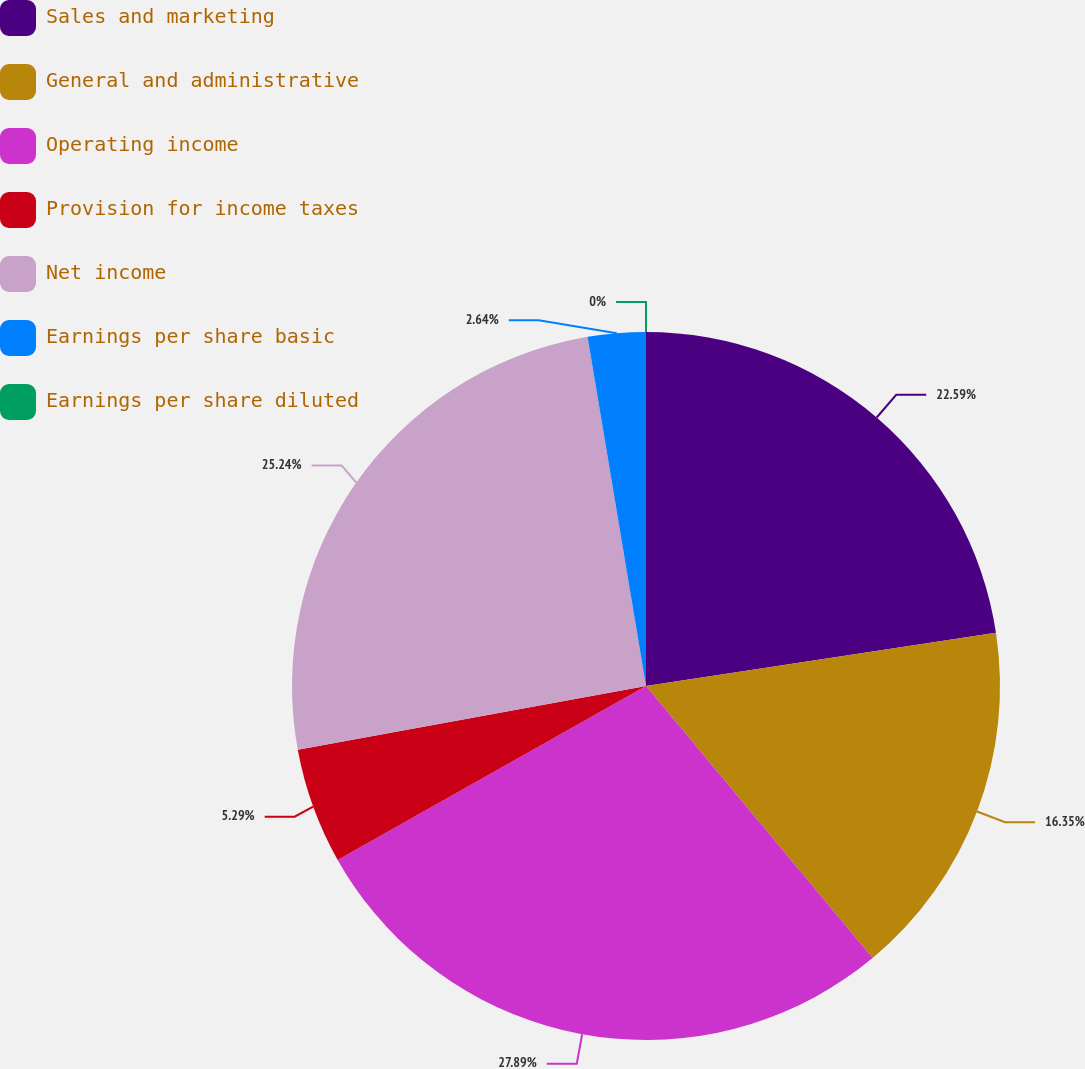<chart> <loc_0><loc_0><loc_500><loc_500><pie_chart><fcel>Sales and marketing<fcel>General and administrative<fcel>Operating income<fcel>Provision for income taxes<fcel>Net income<fcel>Earnings per share basic<fcel>Earnings per share diluted<nl><fcel>22.59%<fcel>16.35%<fcel>27.88%<fcel>5.29%<fcel>25.24%<fcel>2.64%<fcel>0.0%<nl></chart> 